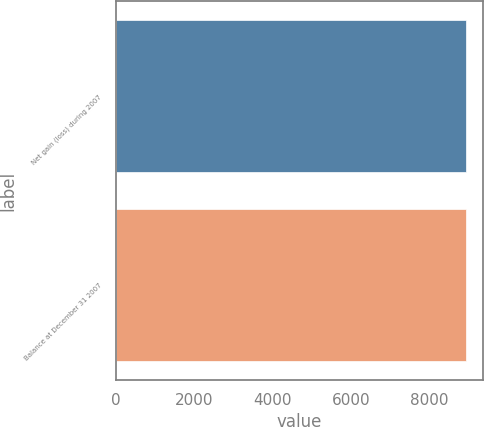Convert chart to OTSL. <chart><loc_0><loc_0><loc_500><loc_500><bar_chart><fcel>Net gain (loss) during 2007<fcel>Balance at December 31 2007<nl><fcel>8931<fcel>8931.1<nl></chart> 